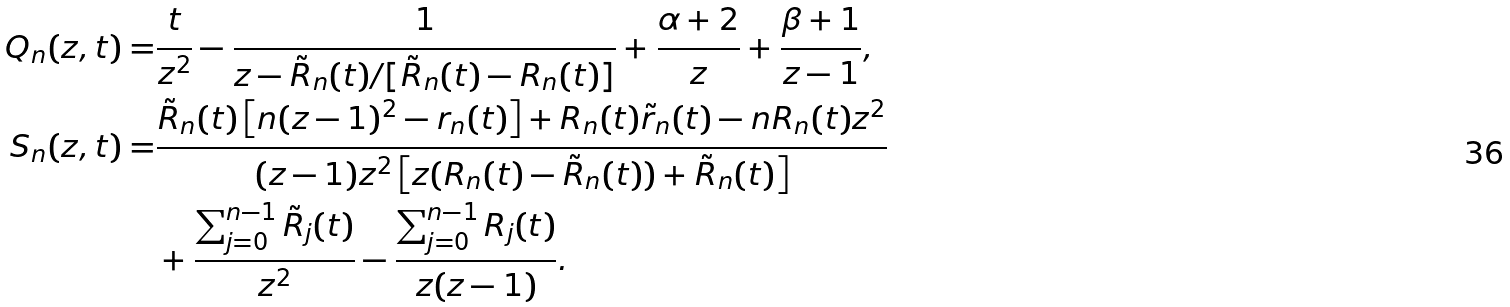<formula> <loc_0><loc_0><loc_500><loc_500>Q _ { n } ( z , t ) = & \frac { t } { z ^ { 2 } } - \frac { 1 } { z - \tilde { R } _ { n } ( t ) / [ \tilde { R } _ { n } ( t ) - R _ { n } ( t ) ] } + \frac { \alpha + 2 } { z } + \frac { \beta + 1 } { z - 1 } , \\ S _ { n } ( z , t ) = & \frac { \tilde { R } _ { n } ( t ) \left [ n ( z - 1 ) ^ { 2 } - r _ { n } ( t ) \right ] + R _ { n } ( t ) \tilde { r } _ { n } ( t ) - n R _ { n } ( t ) z ^ { 2 } } { ( z - 1 ) z ^ { 2 } \left [ z ( R _ { n } ( t ) - \tilde { R } _ { n } ( t ) ) + \tilde { R } _ { n } ( t ) \right ] } \\ & + \frac { \sum _ { j = 0 } ^ { n - 1 } \tilde { R } _ { j } ( t ) } { z ^ { 2 } } - \frac { \sum _ { j = 0 } ^ { n - 1 } R _ { j } ( t ) } { z ( z - 1 ) } .</formula> 